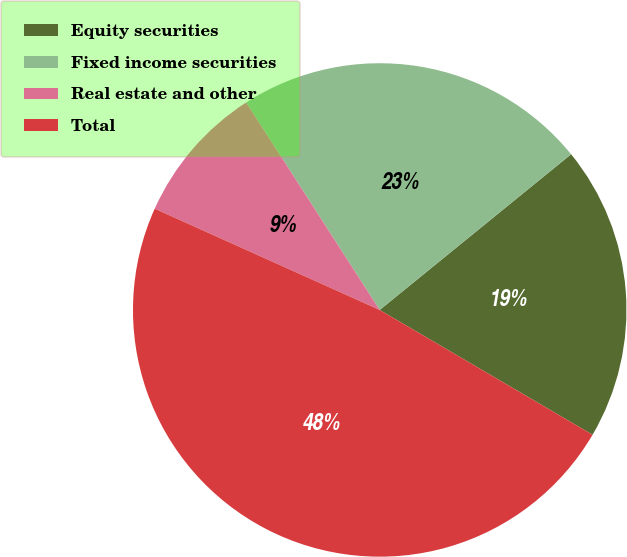Convert chart. <chart><loc_0><loc_0><loc_500><loc_500><pie_chart><fcel>Equity securities<fcel>Fixed income securities<fcel>Real estate and other<fcel>Total<nl><fcel>19.31%<fcel>23.23%<fcel>9.17%<fcel>48.29%<nl></chart> 